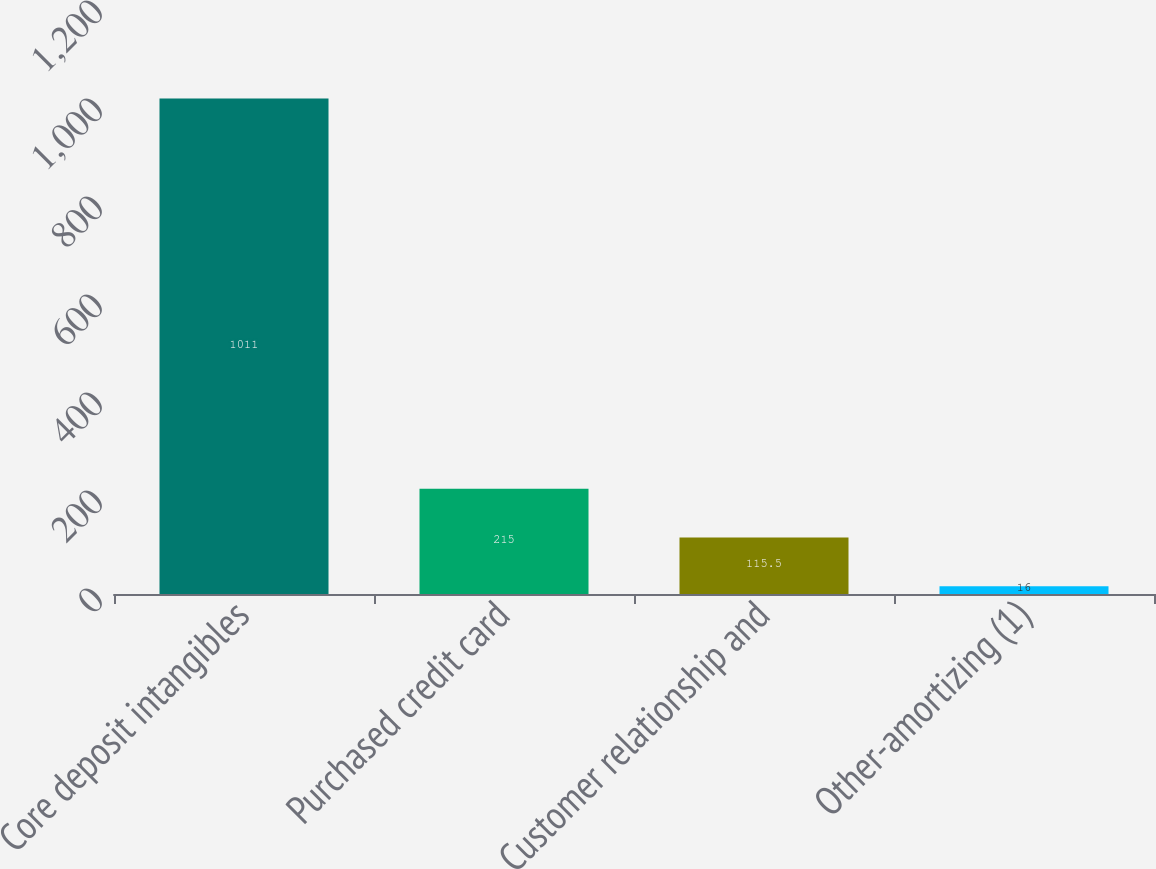Convert chart. <chart><loc_0><loc_0><loc_500><loc_500><bar_chart><fcel>Core deposit intangibles<fcel>Purchased credit card<fcel>Customer relationship and<fcel>Other-amortizing (1)<nl><fcel>1011<fcel>215<fcel>115.5<fcel>16<nl></chart> 